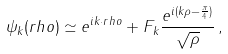Convert formula to latex. <formula><loc_0><loc_0><loc_500><loc_500>\psi _ { k } ( r h o ) \simeq e ^ { i k \cdot r h o } + F _ { k } \frac { e ^ { i ( k \rho - \frac { \pi } { 4 } ) } } { \sqrt { \rho } } \, ,</formula> 